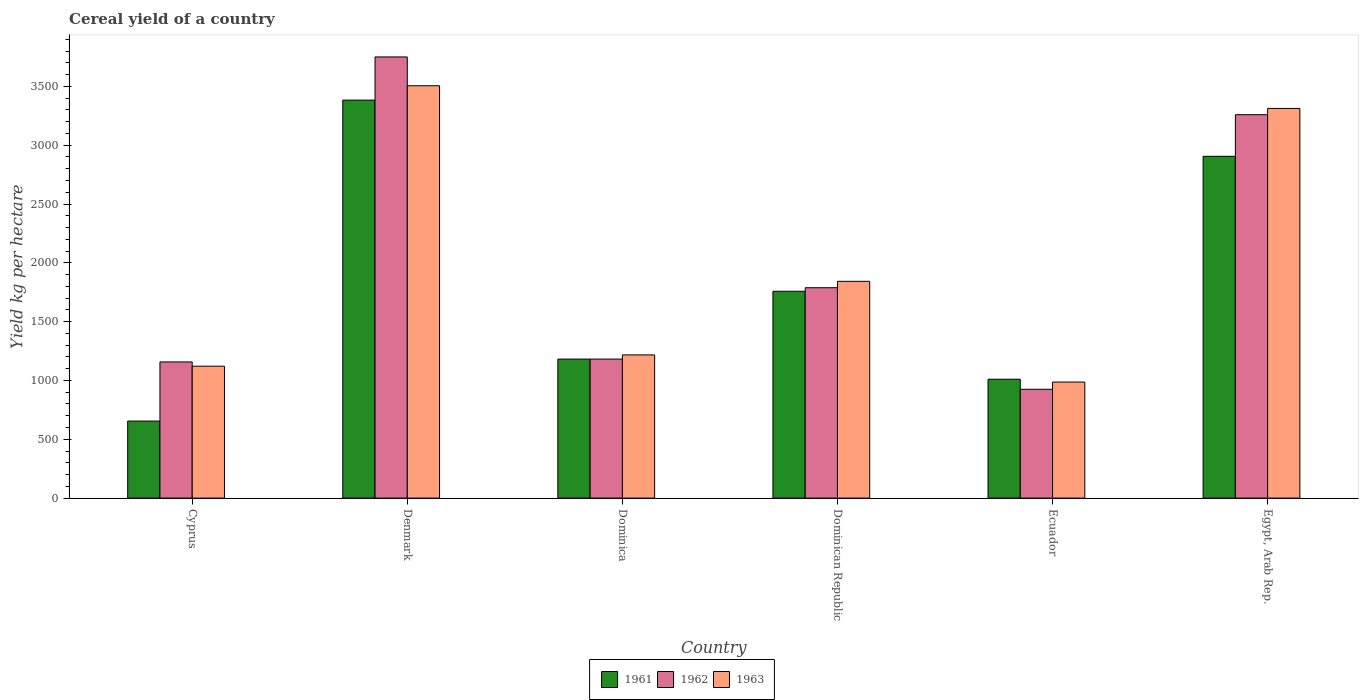How many groups of bars are there?
Keep it short and to the point. 6. Are the number of bars per tick equal to the number of legend labels?
Offer a very short reply. Yes. Are the number of bars on each tick of the X-axis equal?
Your answer should be compact. Yes. How many bars are there on the 4th tick from the left?
Make the answer very short. 3. What is the label of the 4th group of bars from the left?
Ensure brevity in your answer.  Dominican Republic. What is the total cereal yield in 1961 in Ecuador?
Give a very brief answer. 1010.65. Across all countries, what is the maximum total cereal yield in 1961?
Offer a very short reply. 3383.48. Across all countries, what is the minimum total cereal yield in 1961?
Make the answer very short. 654.75. In which country was the total cereal yield in 1961 maximum?
Make the answer very short. Denmark. In which country was the total cereal yield in 1961 minimum?
Ensure brevity in your answer.  Cyprus. What is the total total cereal yield in 1963 in the graph?
Your answer should be very brief. 1.20e+04. What is the difference between the total cereal yield in 1963 in Dominica and that in Ecuador?
Give a very brief answer. 230.93. What is the difference between the total cereal yield in 1961 in Dominican Republic and the total cereal yield in 1962 in Ecuador?
Provide a short and direct response. 833.3. What is the average total cereal yield in 1962 per country?
Keep it short and to the point. 2010.54. What is the difference between the total cereal yield of/in 1963 and total cereal yield of/in 1961 in Dominican Republic?
Provide a succinct answer. 84.45. In how many countries, is the total cereal yield in 1962 greater than 800 kg per hectare?
Your response must be concise. 6. What is the ratio of the total cereal yield in 1963 in Dominica to that in Egypt, Arab Rep.?
Keep it short and to the point. 0.37. Is the total cereal yield in 1963 in Denmark less than that in Egypt, Arab Rep.?
Your response must be concise. No. What is the difference between the highest and the second highest total cereal yield in 1963?
Provide a succinct answer. -192.88. What is the difference between the highest and the lowest total cereal yield in 1962?
Offer a terse response. 2825.55. What does the 2nd bar from the left in Cyprus represents?
Your response must be concise. 1962. What does the 2nd bar from the right in Cyprus represents?
Provide a short and direct response. 1962. How many bars are there?
Offer a very short reply. 18. Are all the bars in the graph horizontal?
Your answer should be very brief. No. Does the graph contain grids?
Keep it short and to the point. No. How many legend labels are there?
Provide a succinct answer. 3. How are the legend labels stacked?
Ensure brevity in your answer.  Horizontal. What is the title of the graph?
Provide a short and direct response. Cereal yield of a country. Does "1967" appear as one of the legend labels in the graph?
Offer a very short reply. No. What is the label or title of the Y-axis?
Your answer should be compact. Yield kg per hectare. What is the Yield kg per hectare of 1961 in Cyprus?
Keep it short and to the point. 654.75. What is the Yield kg per hectare of 1962 in Cyprus?
Ensure brevity in your answer.  1157.61. What is the Yield kg per hectare in 1963 in Cyprus?
Offer a very short reply. 1121.33. What is the Yield kg per hectare of 1961 in Denmark?
Offer a terse response. 3383.48. What is the Yield kg per hectare in 1962 in Denmark?
Provide a succinct answer. 3750.59. What is the Yield kg per hectare of 1963 in Denmark?
Provide a succinct answer. 3505.68. What is the Yield kg per hectare of 1961 in Dominica?
Provide a short and direct response. 1181.82. What is the Yield kg per hectare in 1962 in Dominica?
Give a very brief answer. 1181.82. What is the Yield kg per hectare in 1963 in Dominica?
Make the answer very short. 1217.39. What is the Yield kg per hectare in 1961 in Dominican Republic?
Keep it short and to the point. 1758.35. What is the Yield kg per hectare of 1962 in Dominican Republic?
Offer a very short reply. 1788.62. What is the Yield kg per hectare of 1963 in Dominican Republic?
Offer a very short reply. 1842.8. What is the Yield kg per hectare in 1961 in Ecuador?
Make the answer very short. 1010.65. What is the Yield kg per hectare in 1962 in Ecuador?
Keep it short and to the point. 925.04. What is the Yield kg per hectare in 1963 in Ecuador?
Make the answer very short. 986.46. What is the Yield kg per hectare in 1961 in Egypt, Arab Rep.?
Keep it short and to the point. 2905.73. What is the Yield kg per hectare of 1962 in Egypt, Arab Rep.?
Keep it short and to the point. 3259.56. What is the Yield kg per hectare of 1963 in Egypt, Arab Rep.?
Make the answer very short. 3312.81. Across all countries, what is the maximum Yield kg per hectare in 1961?
Give a very brief answer. 3383.48. Across all countries, what is the maximum Yield kg per hectare of 1962?
Offer a very short reply. 3750.59. Across all countries, what is the maximum Yield kg per hectare of 1963?
Offer a terse response. 3505.68. Across all countries, what is the minimum Yield kg per hectare in 1961?
Offer a terse response. 654.75. Across all countries, what is the minimum Yield kg per hectare in 1962?
Offer a terse response. 925.04. Across all countries, what is the minimum Yield kg per hectare in 1963?
Your answer should be compact. 986.46. What is the total Yield kg per hectare in 1961 in the graph?
Offer a very short reply. 1.09e+04. What is the total Yield kg per hectare in 1962 in the graph?
Make the answer very short. 1.21e+04. What is the total Yield kg per hectare in 1963 in the graph?
Give a very brief answer. 1.20e+04. What is the difference between the Yield kg per hectare in 1961 in Cyprus and that in Denmark?
Your response must be concise. -2728.72. What is the difference between the Yield kg per hectare in 1962 in Cyprus and that in Denmark?
Your answer should be compact. -2592.98. What is the difference between the Yield kg per hectare of 1963 in Cyprus and that in Denmark?
Your answer should be very brief. -2384.35. What is the difference between the Yield kg per hectare in 1961 in Cyprus and that in Dominica?
Offer a terse response. -527.06. What is the difference between the Yield kg per hectare of 1962 in Cyprus and that in Dominica?
Offer a terse response. -24.21. What is the difference between the Yield kg per hectare in 1963 in Cyprus and that in Dominica?
Provide a succinct answer. -96.06. What is the difference between the Yield kg per hectare in 1961 in Cyprus and that in Dominican Republic?
Make the answer very short. -1103.59. What is the difference between the Yield kg per hectare in 1962 in Cyprus and that in Dominican Republic?
Give a very brief answer. -631. What is the difference between the Yield kg per hectare of 1963 in Cyprus and that in Dominican Republic?
Offer a terse response. -721.47. What is the difference between the Yield kg per hectare in 1961 in Cyprus and that in Ecuador?
Make the answer very short. -355.9. What is the difference between the Yield kg per hectare in 1962 in Cyprus and that in Ecuador?
Give a very brief answer. 232.57. What is the difference between the Yield kg per hectare in 1963 in Cyprus and that in Ecuador?
Your answer should be very brief. 134.87. What is the difference between the Yield kg per hectare of 1961 in Cyprus and that in Egypt, Arab Rep.?
Your answer should be compact. -2250.97. What is the difference between the Yield kg per hectare of 1962 in Cyprus and that in Egypt, Arab Rep.?
Your response must be concise. -2101.95. What is the difference between the Yield kg per hectare of 1963 in Cyprus and that in Egypt, Arab Rep.?
Give a very brief answer. -2191.48. What is the difference between the Yield kg per hectare of 1961 in Denmark and that in Dominica?
Provide a short and direct response. 2201.66. What is the difference between the Yield kg per hectare in 1962 in Denmark and that in Dominica?
Provide a short and direct response. 2568.78. What is the difference between the Yield kg per hectare in 1963 in Denmark and that in Dominica?
Keep it short and to the point. 2288.29. What is the difference between the Yield kg per hectare of 1961 in Denmark and that in Dominican Republic?
Make the answer very short. 1625.13. What is the difference between the Yield kg per hectare of 1962 in Denmark and that in Dominican Republic?
Your answer should be very brief. 1961.98. What is the difference between the Yield kg per hectare in 1963 in Denmark and that in Dominican Republic?
Give a very brief answer. 1662.88. What is the difference between the Yield kg per hectare in 1961 in Denmark and that in Ecuador?
Offer a terse response. 2372.82. What is the difference between the Yield kg per hectare of 1962 in Denmark and that in Ecuador?
Offer a terse response. 2825.55. What is the difference between the Yield kg per hectare in 1963 in Denmark and that in Ecuador?
Your answer should be very brief. 2519.22. What is the difference between the Yield kg per hectare of 1961 in Denmark and that in Egypt, Arab Rep.?
Offer a terse response. 477.75. What is the difference between the Yield kg per hectare of 1962 in Denmark and that in Egypt, Arab Rep.?
Provide a succinct answer. 491.04. What is the difference between the Yield kg per hectare of 1963 in Denmark and that in Egypt, Arab Rep.?
Your response must be concise. 192.88. What is the difference between the Yield kg per hectare of 1961 in Dominica and that in Dominican Republic?
Ensure brevity in your answer.  -576.53. What is the difference between the Yield kg per hectare in 1962 in Dominica and that in Dominican Republic?
Make the answer very short. -606.8. What is the difference between the Yield kg per hectare of 1963 in Dominica and that in Dominican Republic?
Make the answer very short. -625.41. What is the difference between the Yield kg per hectare of 1961 in Dominica and that in Ecuador?
Provide a short and direct response. 171.16. What is the difference between the Yield kg per hectare in 1962 in Dominica and that in Ecuador?
Provide a short and direct response. 256.77. What is the difference between the Yield kg per hectare in 1963 in Dominica and that in Ecuador?
Offer a very short reply. 230.93. What is the difference between the Yield kg per hectare in 1961 in Dominica and that in Egypt, Arab Rep.?
Ensure brevity in your answer.  -1723.91. What is the difference between the Yield kg per hectare in 1962 in Dominica and that in Egypt, Arab Rep.?
Offer a terse response. -2077.74. What is the difference between the Yield kg per hectare in 1963 in Dominica and that in Egypt, Arab Rep.?
Give a very brief answer. -2095.42. What is the difference between the Yield kg per hectare of 1961 in Dominican Republic and that in Ecuador?
Provide a short and direct response. 747.69. What is the difference between the Yield kg per hectare in 1962 in Dominican Republic and that in Ecuador?
Offer a terse response. 863.57. What is the difference between the Yield kg per hectare of 1963 in Dominican Republic and that in Ecuador?
Make the answer very short. 856.34. What is the difference between the Yield kg per hectare in 1961 in Dominican Republic and that in Egypt, Arab Rep.?
Your answer should be very brief. -1147.38. What is the difference between the Yield kg per hectare of 1962 in Dominican Republic and that in Egypt, Arab Rep.?
Make the answer very short. -1470.94. What is the difference between the Yield kg per hectare in 1963 in Dominican Republic and that in Egypt, Arab Rep.?
Provide a succinct answer. -1470.01. What is the difference between the Yield kg per hectare of 1961 in Ecuador and that in Egypt, Arab Rep.?
Give a very brief answer. -1895.07. What is the difference between the Yield kg per hectare in 1962 in Ecuador and that in Egypt, Arab Rep.?
Provide a succinct answer. -2334.51. What is the difference between the Yield kg per hectare in 1963 in Ecuador and that in Egypt, Arab Rep.?
Ensure brevity in your answer.  -2326.35. What is the difference between the Yield kg per hectare in 1961 in Cyprus and the Yield kg per hectare in 1962 in Denmark?
Offer a very short reply. -3095.84. What is the difference between the Yield kg per hectare of 1961 in Cyprus and the Yield kg per hectare of 1963 in Denmark?
Your answer should be compact. -2850.93. What is the difference between the Yield kg per hectare in 1962 in Cyprus and the Yield kg per hectare in 1963 in Denmark?
Give a very brief answer. -2348.07. What is the difference between the Yield kg per hectare of 1961 in Cyprus and the Yield kg per hectare of 1962 in Dominica?
Your answer should be compact. -527.06. What is the difference between the Yield kg per hectare in 1961 in Cyprus and the Yield kg per hectare in 1963 in Dominica?
Make the answer very short. -562.64. What is the difference between the Yield kg per hectare of 1962 in Cyprus and the Yield kg per hectare of 1963 in Dominica?
Provide a succinct answer. -59.78. What is the difference between the Yield kg per hectare of 1961 in Cyprus and the Yield kg per hectare of 1962 in Dominican Republic?
Give a very brief answer. -1133.86. What is the difference between the Yield kg per hectare in 1961 in Cyprus and the Yield kg per hectare in 1963 in Dominican Republic?
Give a very brief answer. -1188.05. What is the difference between the Yield kg per hectare in 1962 in Cyprus and the Yield kg per hectare in 1963 in Dominican Republic?
Your answer should be compact. -685.19. What is the difference between the Yield kg per hectare in 1961 in Cyprus and the Yield kg per hectare in 1962 in Ecuador?
Provide a succinct answer. -270.29. What is the difference between the Yield kg per hectare in 1961 in Cyprus and the Yield kg per hectare in 1963 in Ecuador?
Give a very brief answer. -331.7. What is the difference between the Yield kg per hectare of 1962 in Cyprus and the Yield kg per hectare of 1963 in Ecuador?
Ensure brevity in your answer.  171.15. What is the difference between the Yield kg per hectare in 1961 in Cyprus and the Yield kg per hectare in 1962 in Egypt, Arab Rep.?
Make the answer very short. -2604.8. What is the difference between the Yield kg per hectare in 1961 in Cyprus and the Yield kg per hectare in 1963 in Egypt, Arab Rep.?
Offer a terse response. -2658.05. What is the difference between the Yield kg per hectare of 1962 in Cyprus and the Yield kg per hectare of 1963 in Egypt, Arab Rep.?
Ensure brevity in your answer.  -2155.2. What is the difference between the Yield kg per hectare in 1961 in Denmark and the Yield kg per hectare in 1962 in Dominica?
Your answer should be compact. 2201.66. What is the difference between the Yield kg per hectare in 1961 in Denmark and the Yield kg per hectare in 1963 in Dominica?
Offer a terse response. 2166.09. What is the difference between the Yield kg per hectare of 1962 in Denmark and the Yield kg per hectare of 1963 in Dominica?
Provide a short and direct response. 2533.2. What is the difference between the Yield kg per hectare of 1961 in Denmark and the Yield kg per hectare of 1962 in Dominican Republic?
Your answer should be very brief. 1594.86. What is the difference between the Yield kg per hectare of 1961 in Denmark and the Yield kg per hectare of 1963 in Dominican Republic?
Provide a succinct answer. 1540.68. What is the difference between the Yield kg per hectare in 1962 in Denmark and the Yield kg per hectare in 1963 in Dominican Republic?
Offer a very short reply. 1907.79. What is the difference between the Yield kg per hectare in 1961 in Denmark and the Yield kg per hectare in 1962 in Ecuador?
Offer a terse response. 2458.43. What is the difference between the Yield kg per hectare in 1961 in Denmark and the Yield kg per hectare in 1963 in Ecuador?
Provide a short and direct response. 2397.02. What is the difference between the Yield kg per hectare of 1962 in Denmark and the Yield kg per hectare of 1963 in Ecuador?
Provide a succinct answer. 2764.14. What is the difference between the Yield kg per hectare of 1961 in Denmark and the Yield kg per hectare of 1962 in Egypt, Arab Rep.?
Your answer should be compact. 123.92. What is the difference between the Yield kg per hectare of 1961 in Denmark and the Yield kg per hectare of 1963 in Egypt, Arab Rep.?
Your answer should be very brief. 70.67. What is the difference between the Yield kg per hectare of 1962 in Denmark and the Yield kg per hectare of 1963 in Egypt, Arab Rep.?
Your response must be concise. 437.79. What is the difference between the Yield kg per hectare in 1961 in Dominica and the Yield kg per hectare in 1962 in Dominican Republic?
Ensure brevity in your answer.  -606.8. What is the difference between the Yield kg per hectare of 1961 in Dominica and the Yield kg per hectare of 1963 in Dominican Republic?
Your response must be concise. -660.98. What is the difference between the Yield kg per hectare in 1962 in Dominica and the Yield kg per hectare in 1963 in Dominican Republic?
Your response must be concise. -660.98. What is the difference between the Yield kg per hectare of 1961 in Dominica and the Yield kg per hectare of 1962 in Ecuador?
Give a very brief answer. 256.77. What is the difference between the Yield kg per hectare of 1961 in Dominica and the Yield kg per hectare of 1963 in Ecuador?
Give a very brief answer. 195.36. What is the difference between the Yield kg per hectare in 1962 in Dominica and the Yield kg per hectare in 1963 in Ecuador?
Give a very brief answer. 195.36. What is the difference between the Yield kg per hectare in 1961 in Dominica and the Yield kg per hectare in 1962 in Egypt, Arab Rep.?
Offer a terse response. -2077.74. What is the difference between the Yield kg per hectare in 1961 in Dominica and the Yield kg per hectare in 1963 in Egypt, Arab Rep.?
Offer a very short reply. -2130.99. What is the difference between the Yield kg per hectare of 1962 in Dominica and the Yield kg per hectare of 1963 in Egypt, Arab Rep.?
Provide a short and direct response. -2130.99. What is the difference between the Yield kg per hectare of 1961 in Dominican Republic and the Yield kg per hectare of 1962 in Ecuador?
Keep it short and to the point. 833.3. What is the difference between the Yield kg per hectare of 1961 in Dominican Republic and the Yield kg per hectare of 1963 in Ecuador?
Offer a very short reply. 771.89. What is the difference between the Yield kg per hectare in 1962 in Dominican Republic and the Yield kg per hectare in 1963 in Ecuador?
Your answer should be very brief. 802.16. What is the difference between the Yield kg per hectare of 1961 in Dominican Republic and the Yield kg per hectare of 1962 in Egypt, Arab Rep.?
Offer a terse response. -1501.21. What is the difference between the Yield kg per hectare of 1961 in Dominican Republic and the Yield kg per hectare of 1963 in Egypt, Arab Rep.?
Provide a short and direct response. -1554.46. What is the difference between the Yield kg per hectare in 1962 in Dominican Republic and the Yield kg per hectare in 1963 in Egypt, Arab Rep.?
Your response must be concise. -1524.19. What is the difference between the Yield kg per hectare in 1961 in Ecuador and the Yield kg per hectare in 1962 in Egypt, Arab Rep.?
Your response must be concise. -2248.9. What is the difference between the Yield kg per hectare in 1961 in Ecuador and the Yield kg per hectare in 1963 in Egypt, Arab Rep.?
Make the answer very short. -2302.15. What is the difference between the Yield kg per hectare of 1962 in Ecuador and the Yield kg per hectare of 1963 in Egypt, Arab Rep.?
Make the answer very short. -2387.76. What is the average Yield kg per hectare in 1961 per country?
Offer a very short reply. 1815.8. What is the average Yield kg per hectare in 1962 per country?
Ensure brevity in your answer.  2010.54. What is the average Yield kg per hectare in 1963 per country?
Offer a terse response. 1997.75. What is the difference between the Yield kg per hectare in 1961 and Yield kg per hectare in 1962 in Cyprus?
Your answer should be very brief. -502.86. What is the difference between the Yield kg per hectare in 1961 and Yield kg per hectare in 1963 in Cyprus?
Your answer should be very brief. -466.57. What is the difference between the Yield kg per hectare in 1962 and Yield kg per hectare in 1963 in Cyprus?
Offer a terse response. 36.28. What is the difference between the Yield kg per hectare of 1961 and Yield kg per hectare of 1962 in Denmark?
Your response must be concise. -367.12. What is the difference between the Yield kg per hectare of 1961 and Yield kg per hectare of 1963 in Denmark?
Offer a terse response. -122.2. What is the difference between the Yield kg per hectare of 1962 and Yield kg per hectare of 1963 in Denmark?
Your response must be concise. 244.91. What is the difference between the Yield kg per hectare of 1961 and Yield kg per hectare of 1962 in Dominica?
Make the answer very short. 0. What is the difference between the Yield kg per hectare of 1961 and Yield kg per hectare of 1963 in Dominica?
Keep it short and to the point. -35.57. What is the difference between the Yield kg per hectare of 1962 and Yield kg per hectare of 1963 in Dominica?
Your answer should be compact. -35.57. What is the difference between the Yield kg per hectare of 1961 and Yield kg per hectare of 1962 in Dominican Republic?
Keep it short and to the point. -30.27. What is the difference between the Yield kg per hectare of 1961 and Yield kg per hectare of 1963 in Dominican Republic?
Make the answer very short. -84.45. What is the difference between the Yield kg per hectare of 1962 and Yield kg per hectare of 1963 in Dominican Republic?
Your response must be concise. -54.19. What is the difference between the Yield kg per hectare in 1961 and Yield kg per hectare in 1962 in Ecuador?
Provide a succinct answer. 85.61. What is the difference between the Yield kg per hectare in 1961 and Yield kg per hectare in 1963 in Ecuador?
Make the answer very short. 24.2. What is the difference between the Yield kg per hectare in 1962 and Yield kg per hectare in 1963 in Ecuador?
Your answer should be very brief. -61.41. What is the difference between the Yield kg per hectare in 1961 and Yield kg per hectare in 1962 in Egypt, Arab Rep.?
Offer a very short reply. -353.83. What is the difference between the Yield kg per hectare of 1961 and Yield kg per hectare of 1963 in Egypt, Arab Rep.?
Offer a terse response. -407.08. What is the difference between the Yield kg per hectare in 1962 and Yield kg per hectare in 1963 in Egypt, Arab Rep.?
Your answer should be compact. -53.25. What is the ratio of the Yield kg per hectare of 1961 in Cyprus to that in Denmark?
Keep it short and to the point. 0.19. What is the ratio of the Yield kg per hectare in 1962 in Cyprus to that in Denmark?
Offer a very short reply. 0.31. What is the ratio of the Yield kg per hectare in 1963 in Cyprus to that in Denmark?
Your answer should be compact. 0.32. What is the ratio of the Yield kg per hectare of 1961 in Cyprus to that in Dominica?
Offer a terse response. 0.55. What is the ratio of the Yield kg per hectare in 1962 in Cyprus to that in Dominica?
Offer a very short reply. 0.98. What is the ratio of the Yield kg per hectare in 1963 in Cyprus to that in Dominica?
Provide a short and direct response. 0.92. What is the ratio of the Yield kg per hectare in 1961 in Cyprus to that in Dominican Republic?
Keep it short and to the point. 0.37. What is the ratio of the Yield kg per hectare in 1962 in Cyprus to that in Dominican Republic?
Give a very brief answer. 0.65. What is the ratio of the Yield kg per hectare of 1963 in Cyprus to that in Dominican Republic?
Your response must be concise. 0.61. What is the ratio of the Yield kg per hectare of 1961 in Cyprus to that in Ecuador?
Your response must be concise. 0.65. What is the ratio of the Yield kg per hectare of 1962 in Cyprus to that in Ecuador?
Keep it short and to the point. 1.25. What is the ratio of the Yield kg per hectare in 1963 in Cyprus to that in Ecuador?
Make the answer very short. 1.14. What is the ratio of the Yield kg per hectare of 1961 in Cyprus to that in Egypt, Arab Rep.?
Make the answer very short. 0.23. What is the ratio of the Yield kg per hectare in 1962 in Cyprus to that in Egypt, Arab Rep.?
Give a very brief answer. 0.36. What is the ratio of the Yield kg per hectare in 1963 in Cyprus to that in Egypt, Arab Rep.?
Make the answer very short. 0.34. What is the ratio of the Yield kg per hectare of 1961 in Denmark to that in Dominica?
Offer a terse response. 2.86. What is the ratio of the Yield kg per hectare in 1962 in Denmark to that in Dominica?
Your response must be concise. 3.17. What is the ratio of the Yield kg per hectare of 1963 in Denmark to that in Dominica?
Offer a very short reply. 2.88. What is the ratio of the Yield kg per hectare in 1961 in Denmark to that in Dominican Republic?
Ensure brevity in your answer.  1.92. What is the ratio of the Yield kg per hectare of 1962 in Denmark to that in Dominican Republic?
Provide a succinct answer. 2.1. What is the ratio of the Yield kg per hectare in 1963 in Denmark to that in Dominican Republic?
Give a very brief answer. 1.9. What is the ratio of the Yield kg per hectare in 1961 in Denmark to that in Ecuador?
Offer a terse response. 3.35. What is the ratio of the Yield kg per hectare in 1962 in Denmark to that in Ecuador?
Ensure brevity in your answer.  4.05. What is the ratio of the Yield kg per hectare in 1963 in Denmark to that in Ecuador?
Make the answer very short. 3.55. What is the ratio of the Yield kg per hectare of 1961 in Denmark to that in Egypt, Arab Rep.?
Provide a short and direct response. 1.16. What is the ratio of the Yield kg per hectare of 1962 in Denmark to that in Egypt, Arab Rep.?
Your response must be concise. 1.15. What is the ratio of the Yield kg per hectare of 1963 in Denmark to that in Egypt, Arab Rep.?
Give a very brief answer. 1.06. What is the ratio of the Yield kg per hectare in 1961 in Dominica to that in Dominican Republic?
Make the answer very short. 0.67. What is the ratio of the Yield kg per hectare in 1962 in Dominica to that in Dominican Republic?
Your answer should be very brief. 0.66. What is the ratio of the Yield kg per hectare in 1963 in Dominica to that in Dominican Republic?
Provide a short and direct response. 0.66. What is the ratio of the Yield kg per hectare in 1961 in Dominica to that in Ecuador?
Provide a succinct answer. 1.17. What is the ratio of the Yield kg per hectare in 1962 in Dominica to that in Ecuador?
Your response must be concise. 1.28. What is the ratio of the Yield kg per hectare in 1963 in Dominica to that in Ecuador?
Your answer should be compact. 1.23. What is the ratio of the Yield kg per hectare of 1961 in Dominica to that in Egypt, Arab Rep.?
Give a very brief answer. 0.41. What is the ratio of the Yield kg per hectare in 1962 in Dominica to that in Egypt, Arab Rep.?
Ensure brevity in your answer.  0.36. What is the ratio of the Yield kg per hectare in 1963 in Dominica to that in Egypt, Arab Rep.?
Give a very brief answer. 0.37. What is the ratio of the Yield kg per hectare in 1961 in Dominican Republic to that in Ecuador?
Your answer should be compact. 1.74. What is the ratio of the Yield kg per hectare of 1962 in Dominican Republic to that in Ecuador?
Ensure brevity in your answer.  1.93. What is the ratio of the Yield kg per hectare of 1963 in Dominican Republic to that in Ecuador?
Provide a succinct answer. 1.87. What is the ratio of the Yield kg per hectare in 1961 in Dominican Republic to that in Egypt, Arab Rep.?
Ensure brevity in your answer.  0.61. What is the ratio of the Yield kg per hectare in 1962 in Dominican Republic to that in Egypt, Arab Rep.?
Your answer should be compact. 0.55. What is the ratio of the Yield kg per hectare in 1963 in Dominican Republic to that in Egypt, Arab Rep.?
Make the answer very short. 0.56. What is the ratio of the Yield kg per hectare in 1961 in Ecuador to that in Egypt, Arab Rep.?
Give a very brief answer. 0.35. What is the ratio of the Yield kg per hectare of 1962 in Ecuador to that in Egypt, Arab Rep.?
Keep it short and to the point. 0.28. What is the ratio of the Yield kg per hectare in 1963 in Ecuador to that in Egypt, Arab Rep.?
Offer a terse response. 0.3. What is the difference between the highest and the second highest Yield kg per hectare in 1961?
Ensure brevity in your answer.  477.75. What is the difference between the highest and the second highest Yield kg per hectare in 1962?
Give a very brief answer. 491.04. What is the difference between the highest and the second highest Yield kg per hectare of 1963?
Your answer should be very brief. 192.88. What is the difference between the highest and the lowest Yield kg per hectare of 1961?
Keep it short and to the point. 2728.72. What is the difference between the highest and the lowest Yield kg per hectare in 1962?
Offer a very short reply. 2825.55. What is the difference between the highest and the lowest Yield kg per hectare in 1963?
Your response must be concise. 2519.22. 